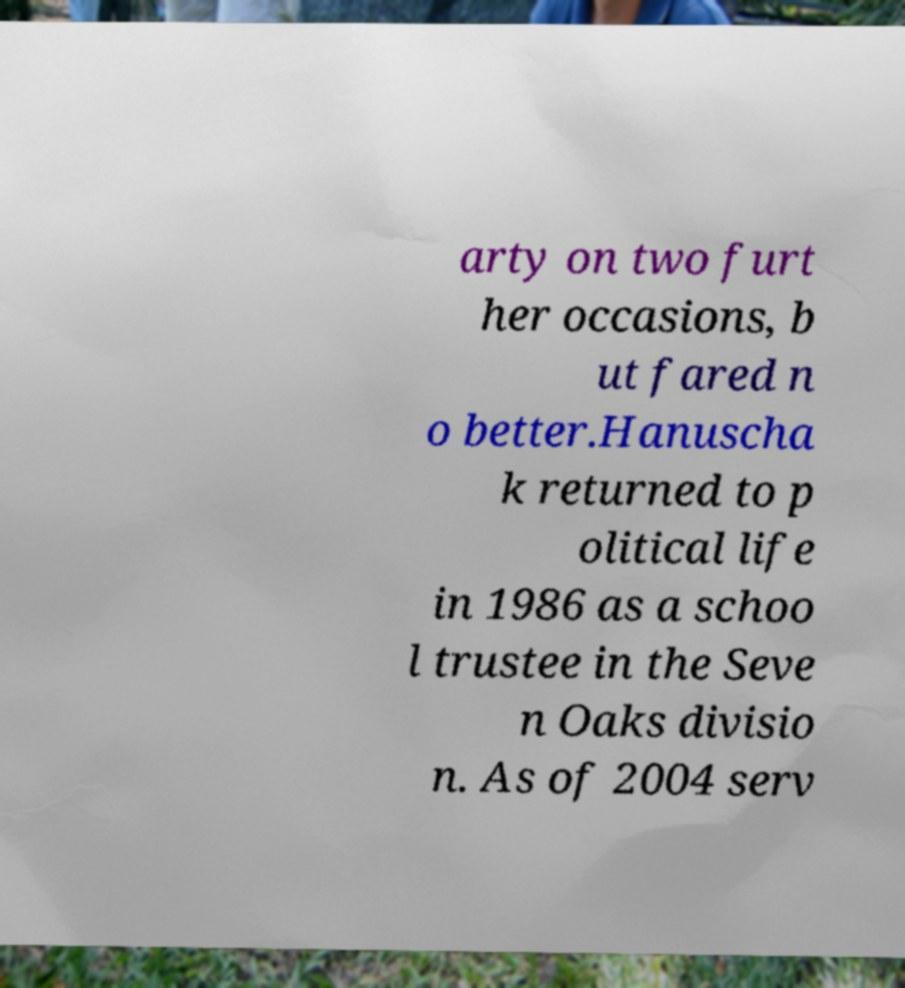Can you accurately transcribe the text from the provided image for me? arty on two furt her occasions, b ut fared n o better.Hanuscha k returned to p olitical life in 1986 as a schoo l trustee in the Seve n Oaks divisio n. As of 2004 serv 